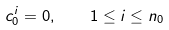<formula> <loc_0><loc_0><loc_500><loc_500>c ^ { i } _ { 0 } = 0 , \quad 1 \leq i \leq n _ { 0 }</formula> 